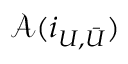<formula> <loc_0><loc_0><loc_500><loc_500>{ \mathcal { A } } ( i _ { U , { \bar { U } } } )</formula> 